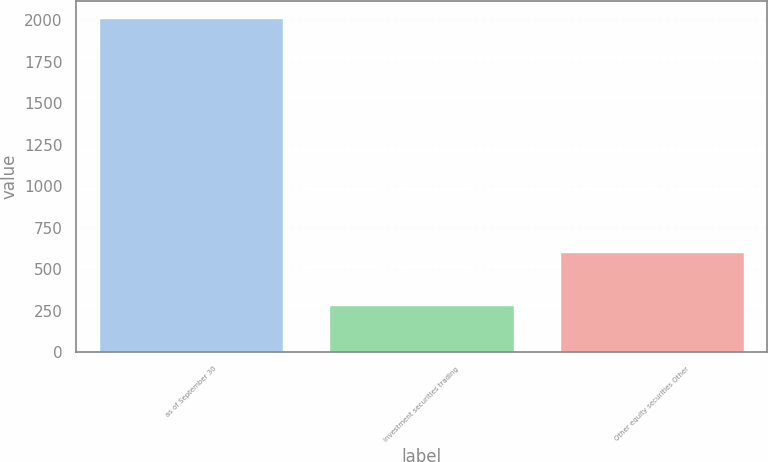Convert chart to OTSL. <chart><loc_0><loc_0><loc_500><loc_500><bar_chart><fcel>as of September 30<fcel>Investment securities trading<fcel>Other equity securities Other<nl><fcel>2016<fcel>287.8<fcel>607.3<nl></chart> 